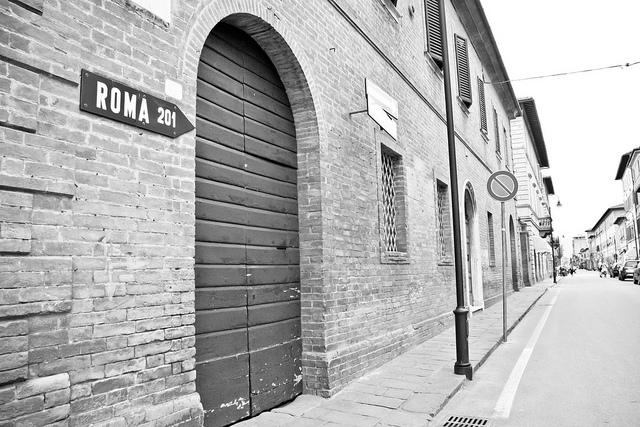What place is this most likely? Please explain your reasoning. rome. The sign on the building indicates this 